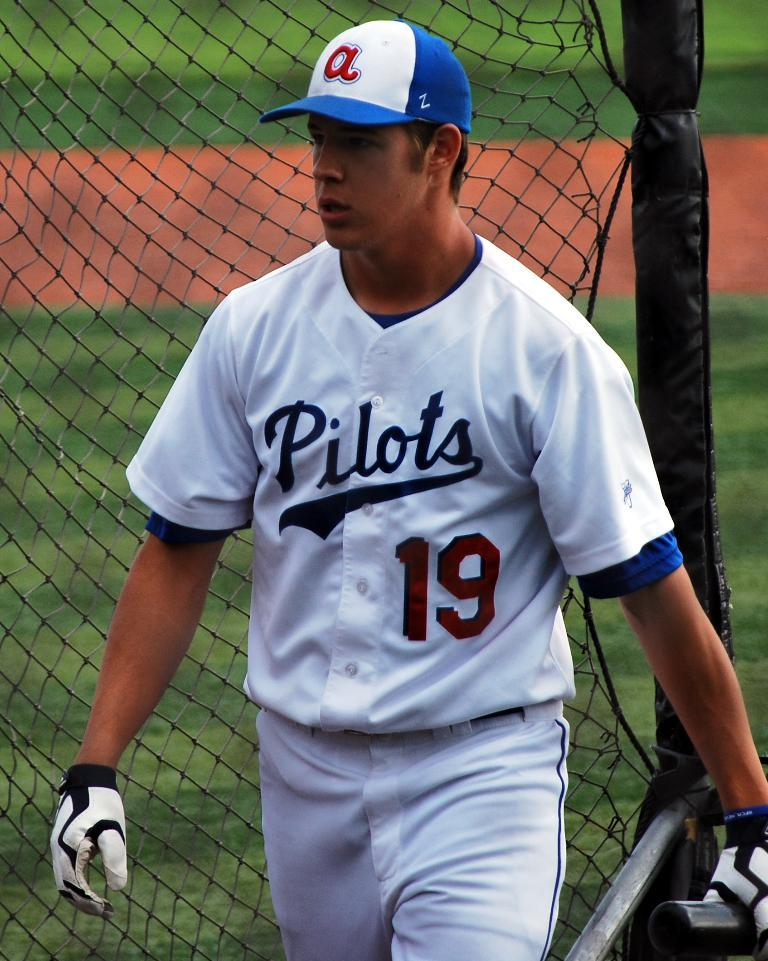<image>
Describe the image concisely. A baseball player stands on the field wearing a white uniform with Pilots across the front in blue and the number 19 in red. 